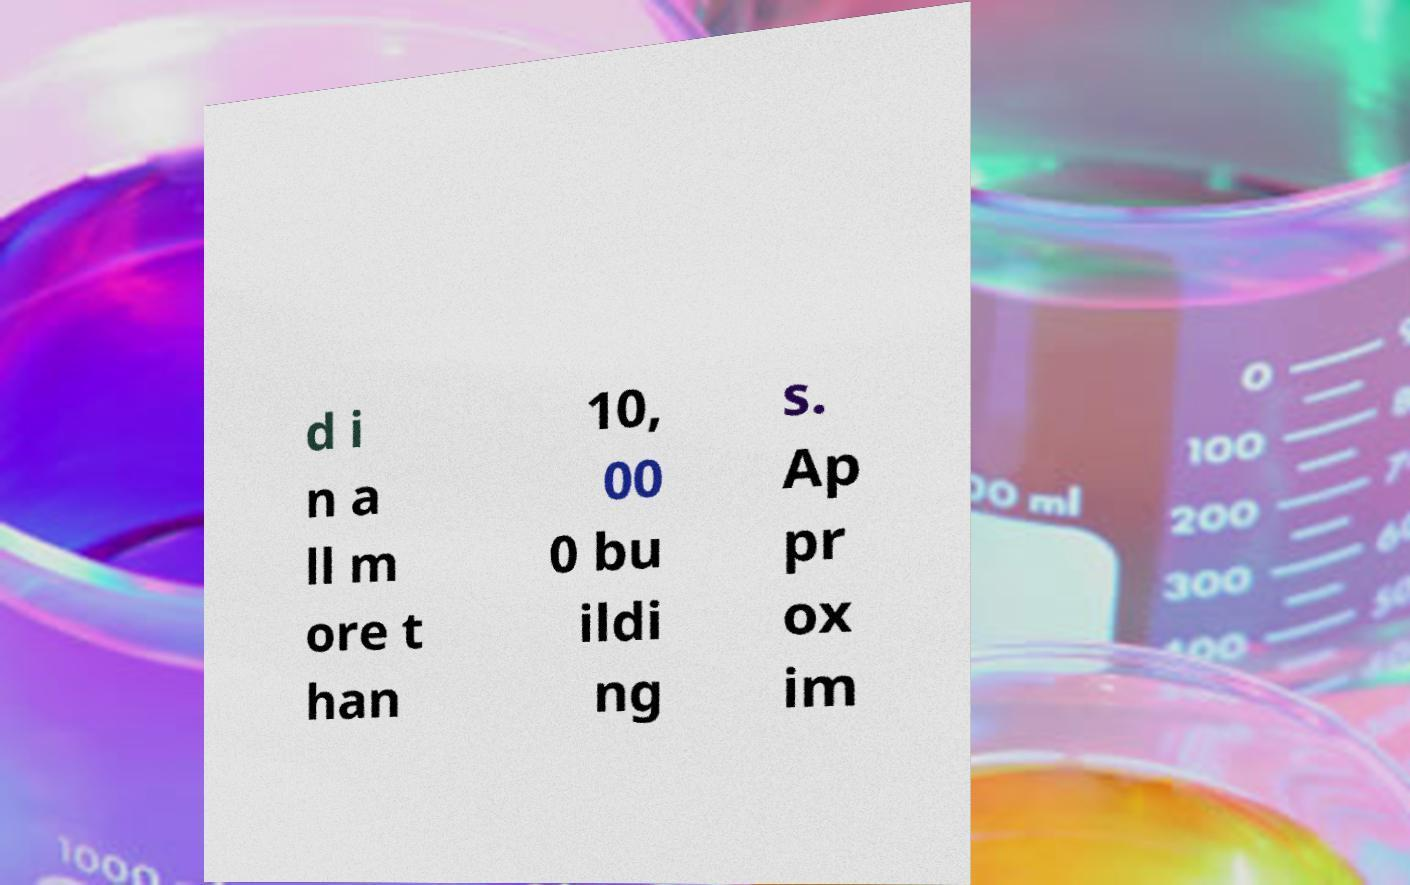Could you assist in decoding the text presented in this image and type it out clearly? d i n a ll m ore t han 10, 00 0 bu ildi ng s. Ap pr ox im 